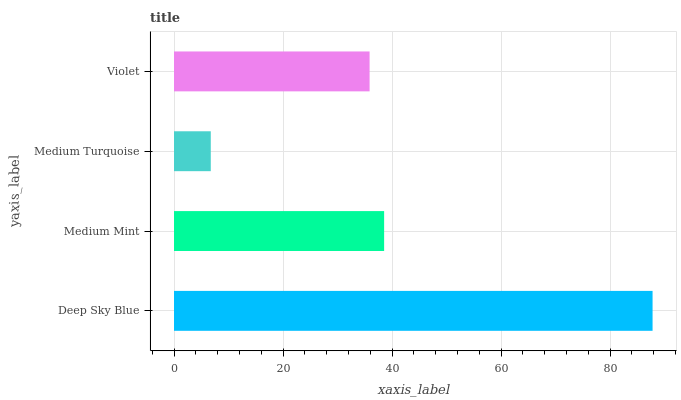Is Medium Turquoise the minimum?
Answer yes or no. Yes. Is Deep Sky Blue the maximum?
Answer yes or no. Yes. Is Medium Mint the minimum?
Answer yes or no. No. Is Medium Mint the maximum?
Answer yes or no. No. Is Deep Sky Blue greater than Medium Mint?
Answer yes or no. Yes. Is Medium Mint less than Deep Sky Blue?
Answer yes or no. Yes. Is Medium Mint greater than Deep Sky Blue?
Answer yes or no. No. Is Deep Sky Blue less than Medium Mint?
Answer yes or no. No. Is Medium Mint the high median?
Answer yes or no. Yes. Is Violet the low median?
Answer yes or no. Yes. Is Deep Sky Blue the high median?
Answer yes or no. No. Is Medium Turquoise the low median?
Answer yes or no. No. 